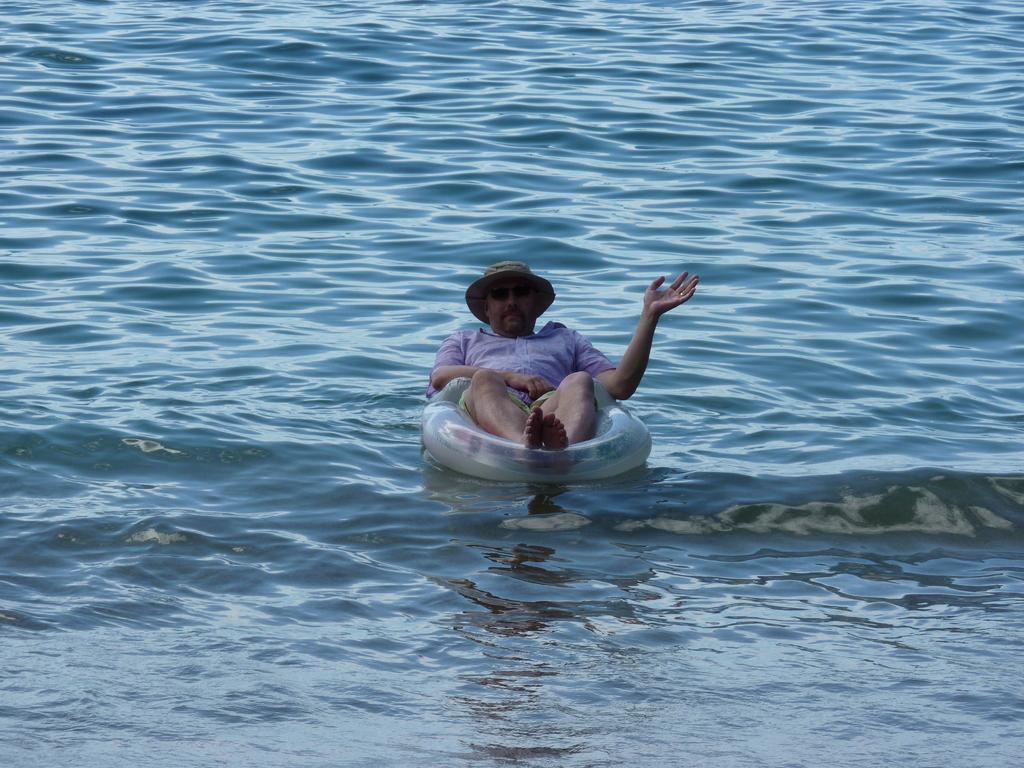In one or two sentences, can you explain what this image depicts? In this image I can see a person sitting on an inner tube on the water. He is wearing a hat. 